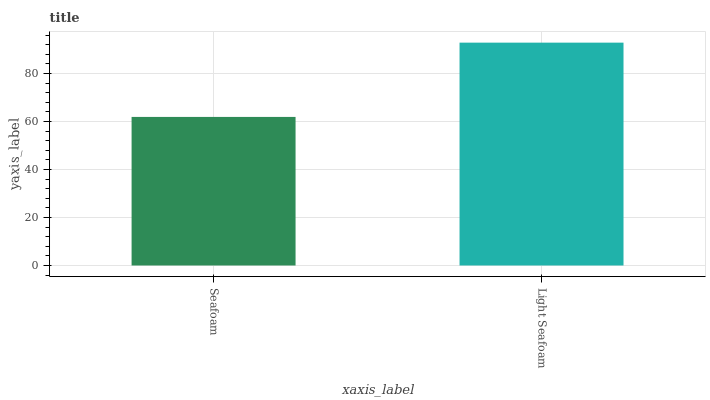Is Seafoam the minimum?
Answer yes or no. Yes. Is Light Seafoam the maximum?
Answer yes or no. Yes. Is Light Seafoam the minimum?
Answer yes or no. No. Is Light Seafoam greater than Seafoam?
Answer yes or no. Yes. Is Seafoam less than Light Seafoam?
Answer yes or no. Yes. Is Seafoam greater than Light Seafoam?
Answer yes or no. No. Is Light Seafoam less than Seafoam?
Answer yes or no. No. Is Light Seafoam the high median?
Answer yes or no. Yes. Is Seafoam the low median?
Answer yes or no. Yes. Is Seafoam the high median?
Answer yes or no. No. Is Light Seafoam the low median?
Answer yes or no. No. 